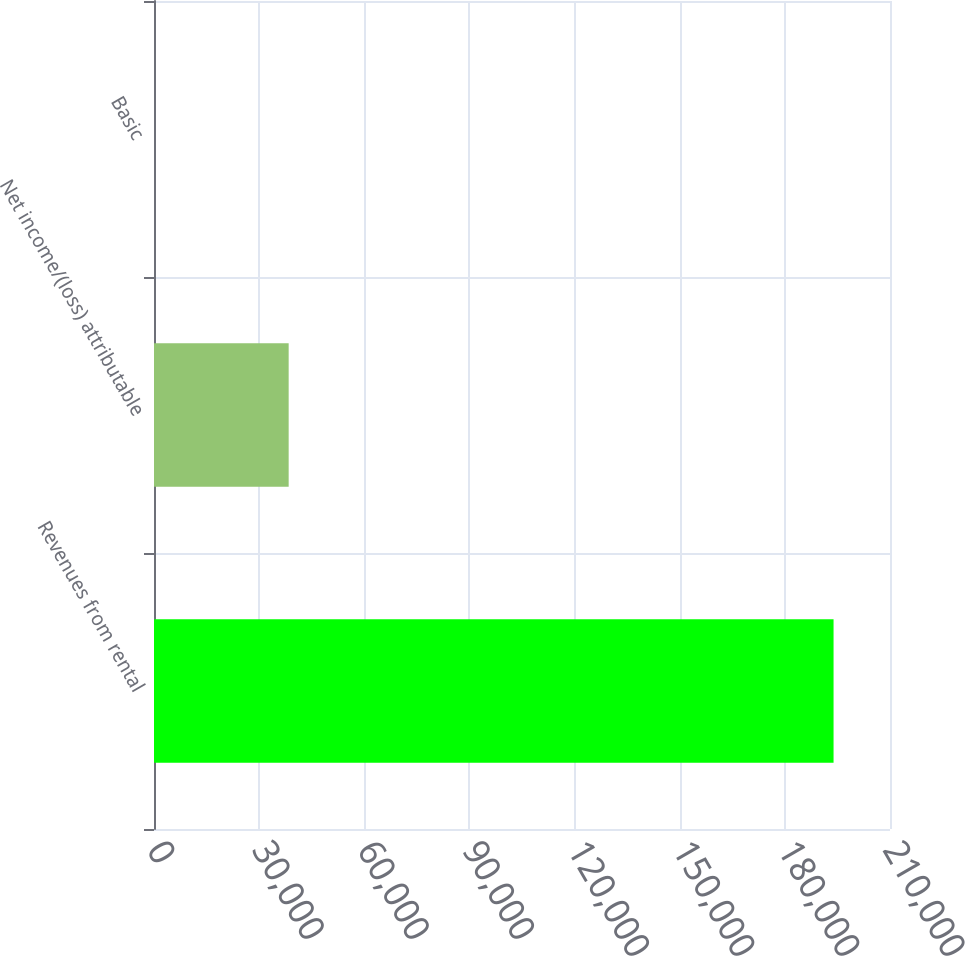<chart> <loc_0><loc_0><loc_500><loc_500><bar_chart><fcel>Revenues from rental<fcel>Net income/(loss) attributable<fcel>Basic<nl><fcel>193895<fcel>38424<fcel>0.1<nl></chart> 